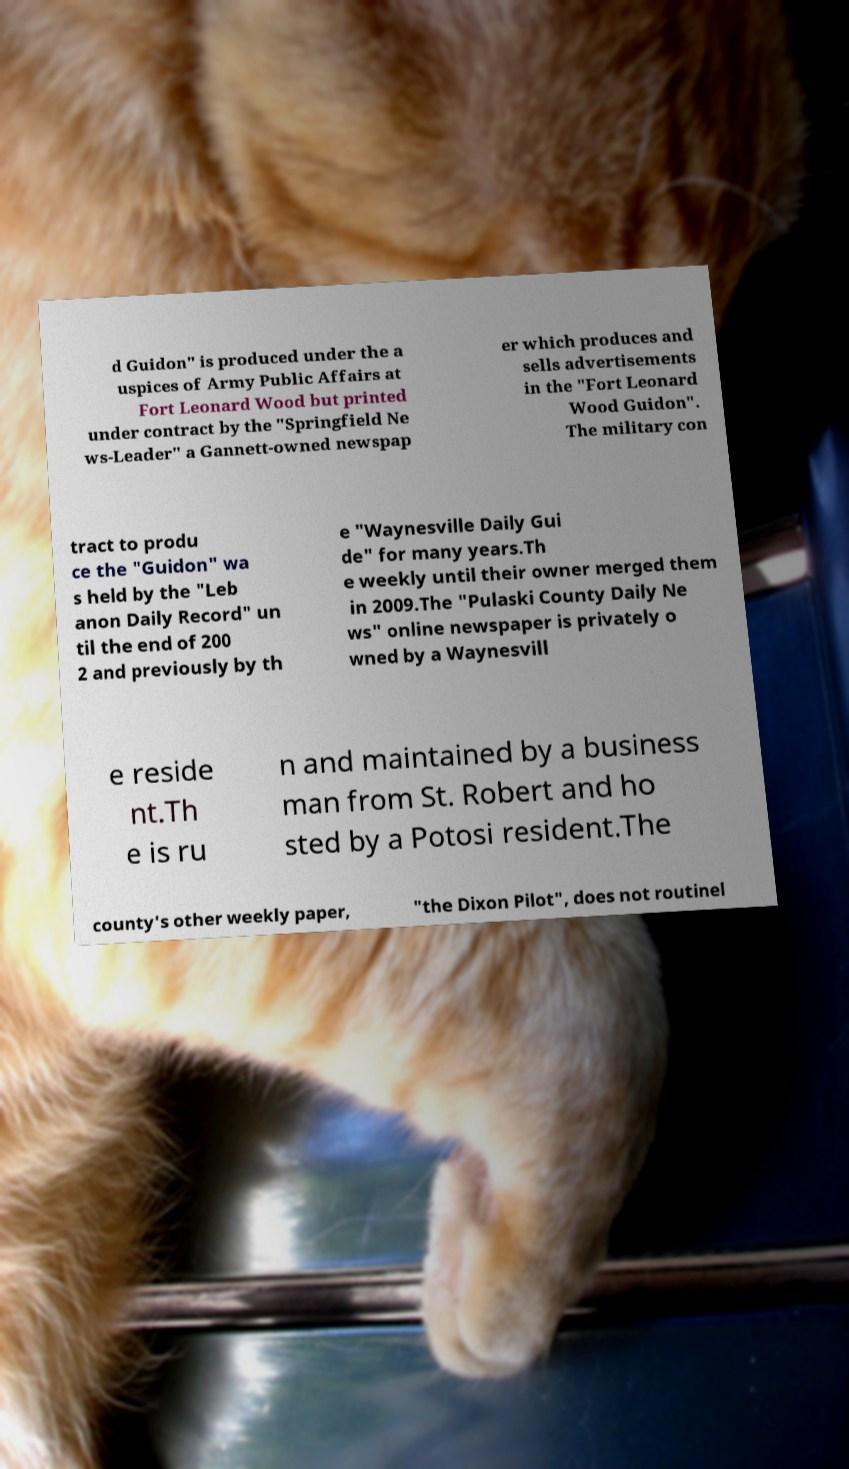I need the written content from this picture converted into text. Can you do that? d Guidon" is produced under the a uspices of Army Public Affairs at Fort Leonard Wood but printed under contract by the "Springfield Ne ws-Leader" a Gannett-owned newspap er which produces and sells advertisements in the "Fort Leonard Wood Guidon". The military con tract to produ ce the "Guidon" wa s held by the "Leb anon Daily Record" un til the end of 200 2 and previously by th e "Waynesville Daily Gui de" for many years.Th e weekly until their owner merged them in 2009.The "Pulaski County Daily Ne ws" online newspaper is privately o wned by a Waynesvill e reside nt.Th e is ru n and maintained by a business man from St. Robert and ho sted by a Potosi resident.The county's other weekly paper, "the Dixon Pilot", does not routinel 